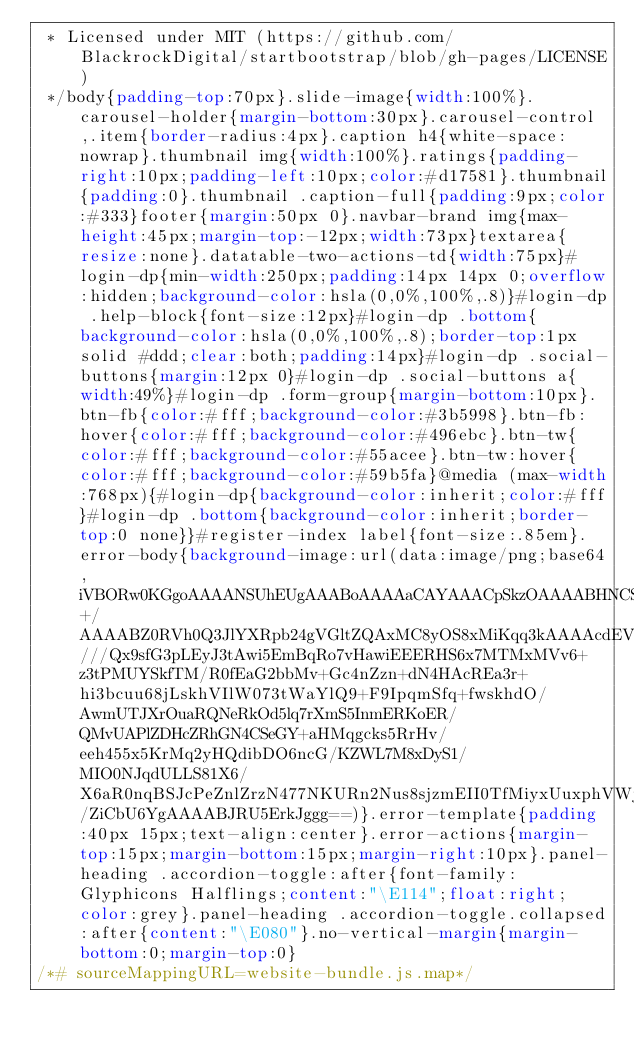<code> <loc_0><loc_0><loc_500><loc_500><_CSS_> * Licensed under MIT (https://github.com/BlackrockDigital/startbootstrap/blob/gh-pages/LICENSE)
 */body{padding-top:70px}.slide-image{width:100%}.carousel-holder{margin-bottom:30px}.carousel-control,.item{border-radius:4px}.caption h4{white-space:nowrap}.thumbnail img{width:100%}.ratings{padding-right:10px;padding-left:10px;color:#d17581}.thumbnail{padding:0}.thumbnail .caption-full{padding:9px;color:#333}footer{margin:50px 0}.navbar-brand img{max-height:45px;margin-top:-12px;width:73px}textarea{resize:none}.datatable-two-actions-td{width:75px}#login-dp{min-width:250px;padding:14px 14px 0;overflow:hidden;background-color:hsla(0,0%,100%,.8)}#login-dp .help-block{font-size:12px}#login-dp .bottom{background-color:hsla(0,0%,100%,.8);border-top:1px solid #ddd;clear:both;padding:14px}#login-dp .social-buttons{margin:12px 0}#login-dp .social-buttons a{width:49%}#login-dp .form-group{margin-bottom:10px}.btn-fb{color:#fff;background-color:#3b5998}.btn-fb:hover{color:#fff;background-color:#496ebc}.btn-tw{color:#fff;background-color:#55acee}.btn-tw:hover{color:#fff;background-color:#59b5fa}@media (max-width:768px){#login-dp{background-color:inherit;color:#fff}#login-dp .bottom{background-color:inherit;border-top:0 none}}#register-index label{font-size:.85em}.error-body{background-image:url(data:image/png;base64,iVBORw0KGgoAAAANSUhEUgAAABoAAAAaCAYAAACpSkzOAAAABHNCSVQICAgIfAhkiAAAAAlwSFlzAAALEgAACxIB0t1+/AAAABZ0RVh0Q3JlYXRpb24gVGltZQAxMC8yOS8xMiKqq3kAAAAcdEVYdFNvZnR3YXJlAEFkb2JlIEZpcmV3b3JrcyBDUzVxteM2AAABHklEQVRIib2Vyw6EIAxFW5idr///Qx9sfG3pLEyJ3tAwi5EmBqRo7vHawiEEERHS6x7MTMxMVv6+z3tPMUYSkfTM/R0fEaG2bbMv+Gc4nZzn+dN4HAcREa3r+hi3bcuu68jLskhVIlW073tWaYlQ9+F9IpqmSfq+fwskhdO/AwmUTJXrOuaRQNeRkOd5lq7rXmS5InmERKoER/QMvUAPlZDHcZRhGN4CSeGY+aHMqgcks5RrHv/eeh455x5KrMq2yHQdibDO6ncG/KZWL7M8xDyS1/MIO0NJqdULLS81X6/X6aR0nqBSJcPeZnlZrzN477NKURn2Nus8sjzmEII0TfMiyxUuxphVWjpJkbx0btUnshRihVv70Bv8ItXq6Asoi/ZiCbU6YgAAAABJRU5ErkJggg==)}.error-template{padding:40px 15px;text-align:center}.error-actions{margin-top:15px;margin-bottom:15px;margin-right:10px}.panel-heading .accordion-toggle:after{font-family:Glyphicons Halflings;content:"\E114";float:right;color:grey}.panel-heading .accordion-toggle.collapsed:after{content:"\E080"}.no-vertical-margin{margin-bottom:0;margin-top:0}
/*# sourceMappingURL=website-bundle.js.map*/</code> 